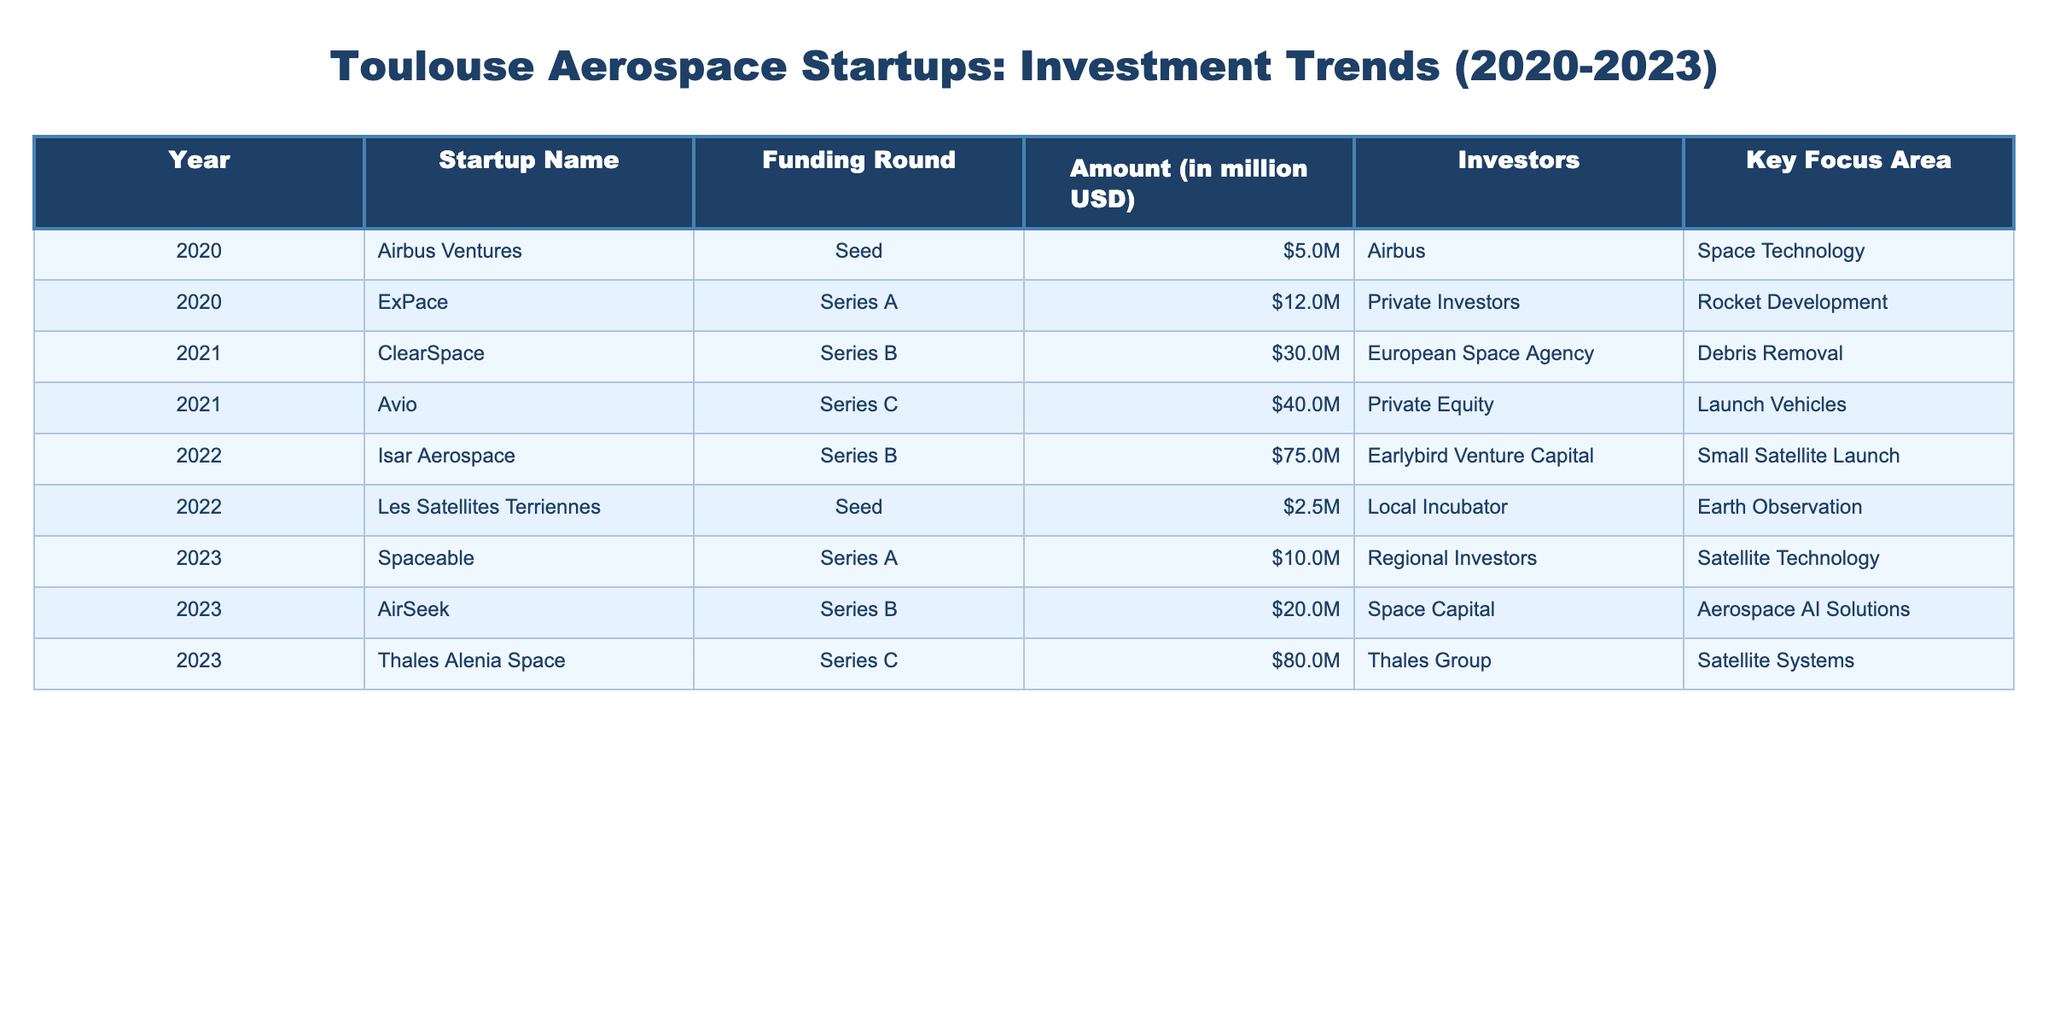What was the total amount of funding received by Isar Aerospace in 2022? According to the table, Isar Aerospace received funding in the amount of 75 million USD in 2022. That's the only entry for Isar Aerospace in the table, so no additional calculations are needed.
Answer: 75 million USD Which startup had the highest funding round in the years listed? By reviewing each amount in the table, Thales Alenia Space received the highest funding round with an amount of 80 million USD in 2023.
Answer: Thales Alenia Space What were the key focus areas for startups receiving seed funding? The startups that received seed funding are Airbus Ventures (Space Technology) and Les Satellites Terriennes (Earth Observation). Therefore, the focus areas for startups receiving seed funding include Space Technology and Earth Observation.
Answer: Space Technology, Earth Observation How much more funding did Avio receive in its funding round compared to ClearSpace? Avio received 40 million USD in its Series C funding round, while ClearSpace received 30 million USD in its Series B round. The difference can be calculated as 40 million USD - 30 million USD = 10 million USD.
Answer: 10 million USD Did any startups receive funding from the European Space Agency? Yes, according to the table, ClearSpace received funding from the European Space Agency in 2021.
Answer: Yes What is the average funding amount of all the startups listed in 2023? First, we need to identify the funding amounts for the startups listed in 2023: Spaceable (10 million USD), AirSeek (20 million USD), and Thales Alenia Space (80 million USD). The total funding for 2023 is 10 million USD + 20 million USD + 80 million USD = 110 million USD. There are 3 startups, so the average is 110 million USD / 3 = approximately 36.67 million USD.
Answer: Approximately 36.67 million USD What year did the startup ExPace receive funding, and what was its amount? The table indicates that ExPace received funding in the year 2020, with an amount of 12 million USD. This information is directly accessible in the table under the corresponding year.
Answer: 2020, 12 million USD Which startup had the highest amount of funding in 2021? In 2021, Avio had the highest funding amount at 40 million USD, while ClearSpace received 30 million USD. By comparing these values, it's confirmed that Avio received the highest funding.
Answer: Avio How much total funding was received across all startups in 2020? The startups receiving funding in 2020 were Airbus Ventures (5 million USD) and ExPace (12 million USD). Adding these amounts together gives a total of 5 million USD + 12 million USD = 17 million USD received in 2020.
Answer: 17 million USD 